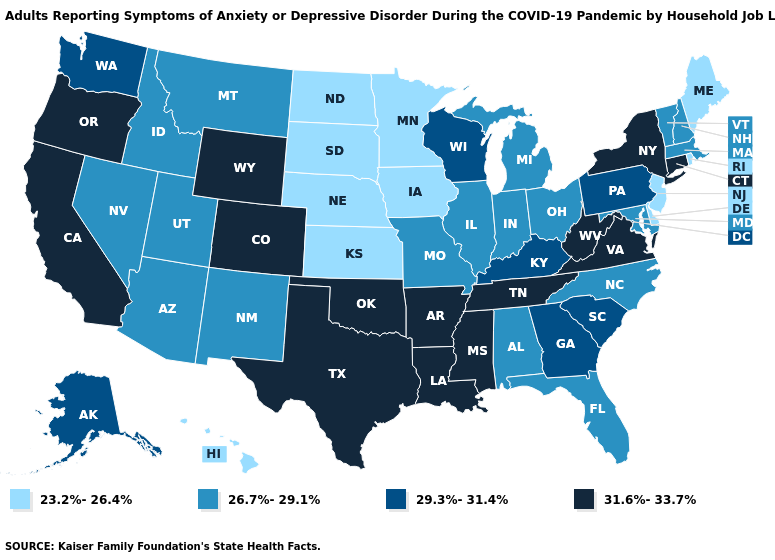Name the states that have a value in the range 23.2%-26.4%?
Be succinct. Delaware, Hawaii, Iowa, Kansas, Maine, Minnesota, Nebraska, New Jersey, North Dakota, Rhode Island, South Dakota. What is the lowest value in states that border South Dakota?
Be succinct. 23.2%-26.4%. Among the states that border Washington , does Idaho have the highest value?
Write a very short answer. No. What is the value of Texas?
Keep it brief. 31.6%-33.7%. Which states have the highest value in the USA?
Quick response, please. Arkansas, California, Colorado, Connecticut, Louisiana, Mississippi, New York, Oklahoma, Oregon, Tennessee, Texas, Virginia, West Virginia, Wyoming. What is the highest value in states that border New York?
Answer briefly. 31.6%-33.7%. What is the highest value in the South ?
Be succinct. 31.6%-33.7%. Is the legend a continuous bar?
Write a very short answer. No. Is the legend a continuous bar?
Short answer required. No. Name the states that have a value in the range 26.7%-29.1%?
Answer briefly. Alabama, Arizona, Florida, Idaho, Illinois, Indiana, Maryland, Massachusetts, Michigan, Missouri, Montana, Nevada, New Hampshire, New Mexico, North Carolina, Ohio, Utah, Vermont. Among the states that border Rhode Island , which have the highest value?
Keep it brief. Connecticut. Is the legend a continuous bar?
Concise answer only. No. Does Indiana have the same value as New Hampshire?
Quick response, please. Yes. What is the highest value in states that border Maine?
Give a very brief answer. 26.7%-29.1%. 